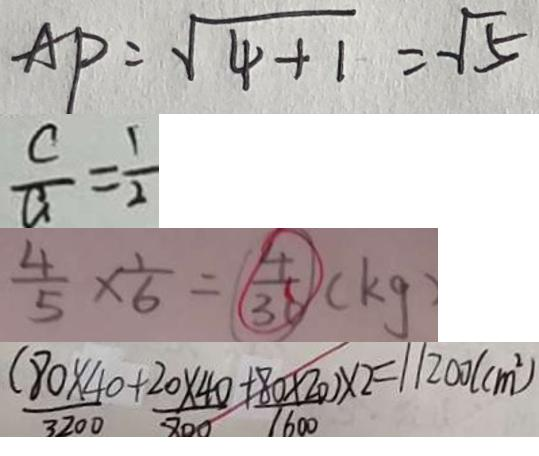<formula> <loc_0><loc_0><loc_500><loc_500>A P = \sqrt { 4 + 1 } = \sqrt { 5 } 
 \frac { c } { a } = \frac { 1 } { 2 } 
 \frac { 4 } { 5 } \times \frac { 1 } { 6 } = \frac { 4 } { 3 6 } ( k g ) 
 ( \frac { 8 0 \times 4 0 } { 3 2 0 0 } + \frac { 2 0 \times 4 0 } { 8 0 0 } + \frac { 8 0 \times 2 0 } { 1 6 0 0 } ) \times 2 = 1 1 2 0 0 ( c m ^ { 2 } )</formula> 